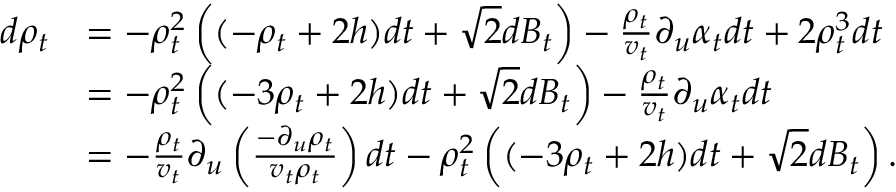<formula> <loc_0><loc_0><loc_500><loc_500>\begin{array} { r l } { d \rho _ { t } } & { = - \rho _ { t } ^ { 2 } \left ( ( - \rho _ { t } + 2 h ) d t + \sqrt { 2 } d B _ { t } \right ) - \frac { \rho _ { t } } { v _ { t } } \partial _ { u } \alpha _ { t } d t + 2 \rho _ { t } ^ { 3 } d t } \\ & { = - \rho _ { t } ^ { 2 } \left ( ( - 3 \rho _ { t } + 2 h ) d t + \sqrt { 2 } d B _ { t } \right ) - \frac { \rho _ { t } } { v _ { t } } \partial _ { u } \alpha _ { t } d t } \\ & { = - \frac { \rho _ { t } } { v _ { t } } \partial _ { u } \left ( \frac { - \partial _ { u } \rho _ { t } } { v _ { t } \rho _ { t } } \right ) d t - \rho _ { t } ^ { 2 } \left ( ( - 3 \rho _ { t } + 2 h ) d t + \sqrt { 2 } d B _ { t } \right ) . } \end{array}</formula> 